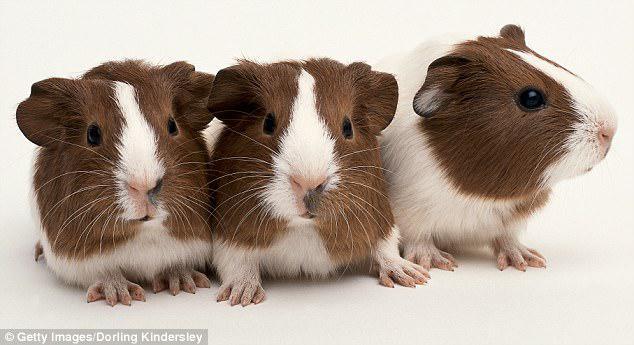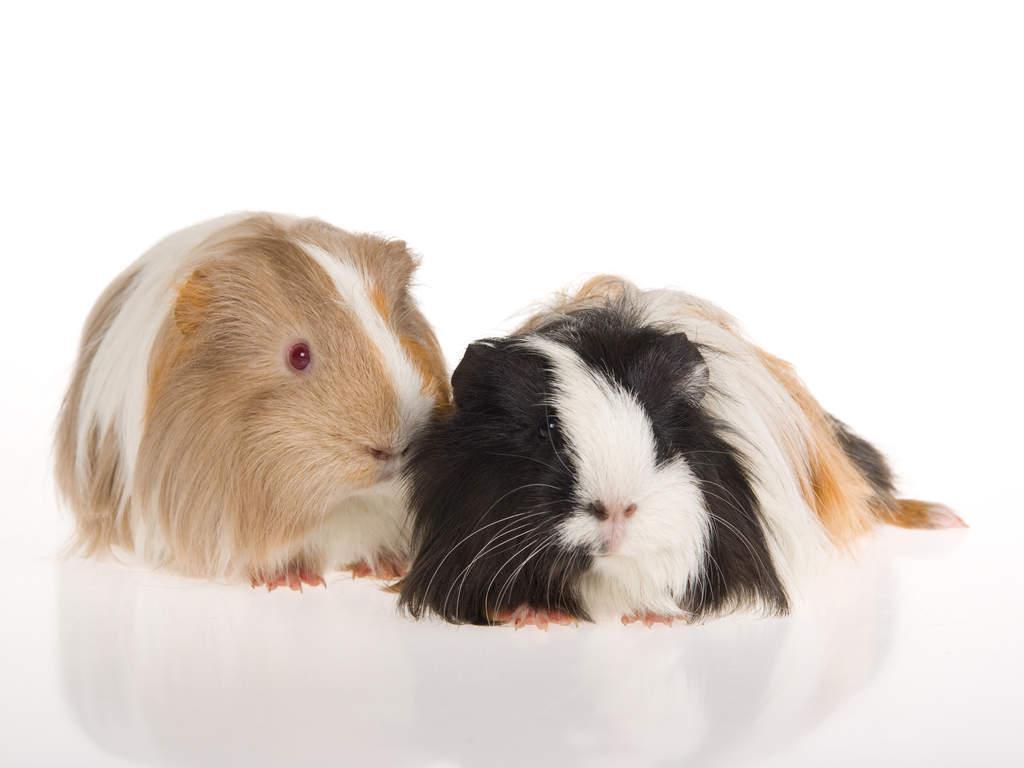The first image is the image on the left, the second image is the image on the right. Considering the images on both sides, is "One image shows a multicolored guinea pig next to a different pet with longer ears." valid? Answer yes or no. No. The first image is the image on the left, the second image is the image on the right. Assess this claim about the two images: "A rabbit is posing with the rodent in one of the images.". Correct or not? Answer yes or no. No. 